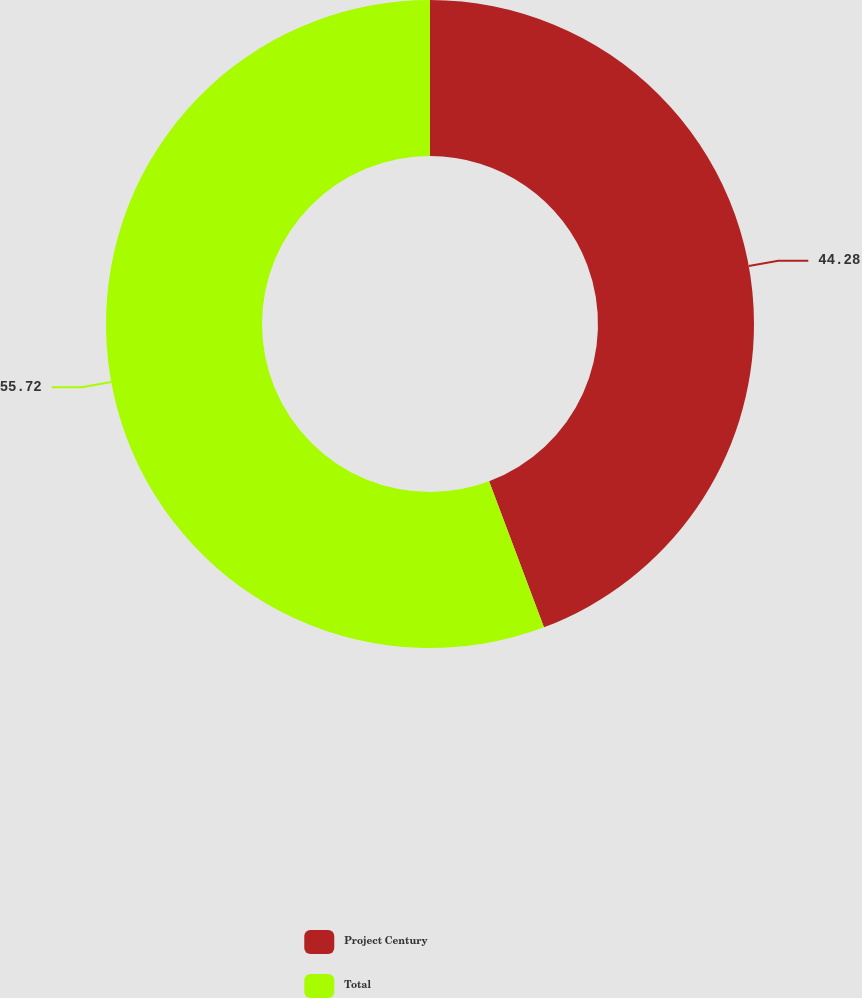<chart> <loc_0><loc_0><loc_500><loc_500><pie_chart><fcel>Project Century<fcel>Total<nl><fcel>44.28%<fcel>55.72%<nl></chart> 